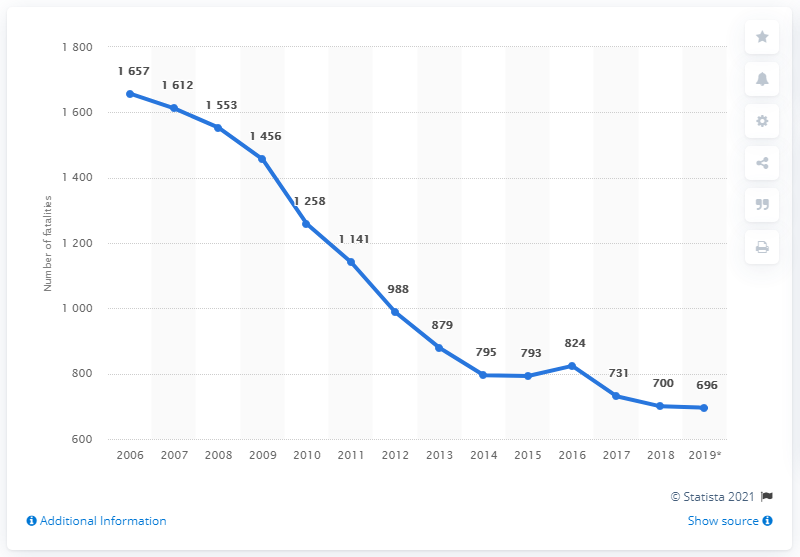Can this data be used to infer the effectiveness of road safety campaigns over time? Although this chart doesn't explicitly measure the impact of road safety campaigns, the downward trend in road fatalities could suggest that such campaigns, alongside other factors, may have been effective. A more detailed analysis involving campaign dates and the nature of these initiatives would be needed to draw a more precise conclusion.  What additional data might be useful to analyze alongside this chart to get a clearer picture of road safety trends? To enhance our understanding of road safety trends, it would be beneficial to analyze data on vehicle miles traveled to see if the decrease in fatalities correlates with less travel or improved safety. Additionally, examining changes in legislation, vehicle technology, and demographic shifts would provide a more comprehensive picture. Data on the types of vehicles involved, road conditions, and driver demographics could also offer deeper insights. 